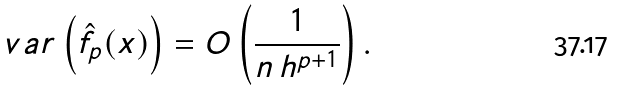Convert formula to latex. <formula><loc_0><loc_0><loc_500><loc_500>\ v a r \left ( \hat { f } _ { p } ( x ) \right ) = O \left ( \frac { 1 } { n \, h ^ { p + 1 } } \right ) .</formula> 